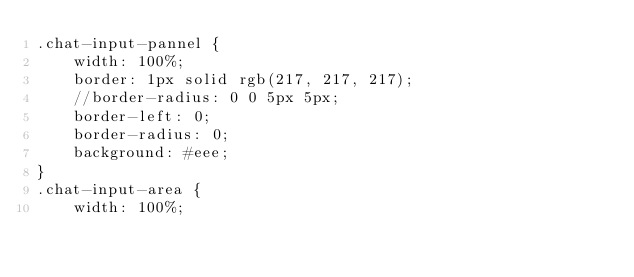Convert code to text. <code><loc_0><loc_0><loc_500><loc_500><_CSS_>.chat-input-pannel {
    width: 100%;
    border: 1px solid rgb(217, 217, 217);
    //border-radius: 0 0 5px 5px;
    border-left: 0;
    border-radius: 0;
    background: #eee;
}
.chat-input-area {
    width: 100%;</code> 